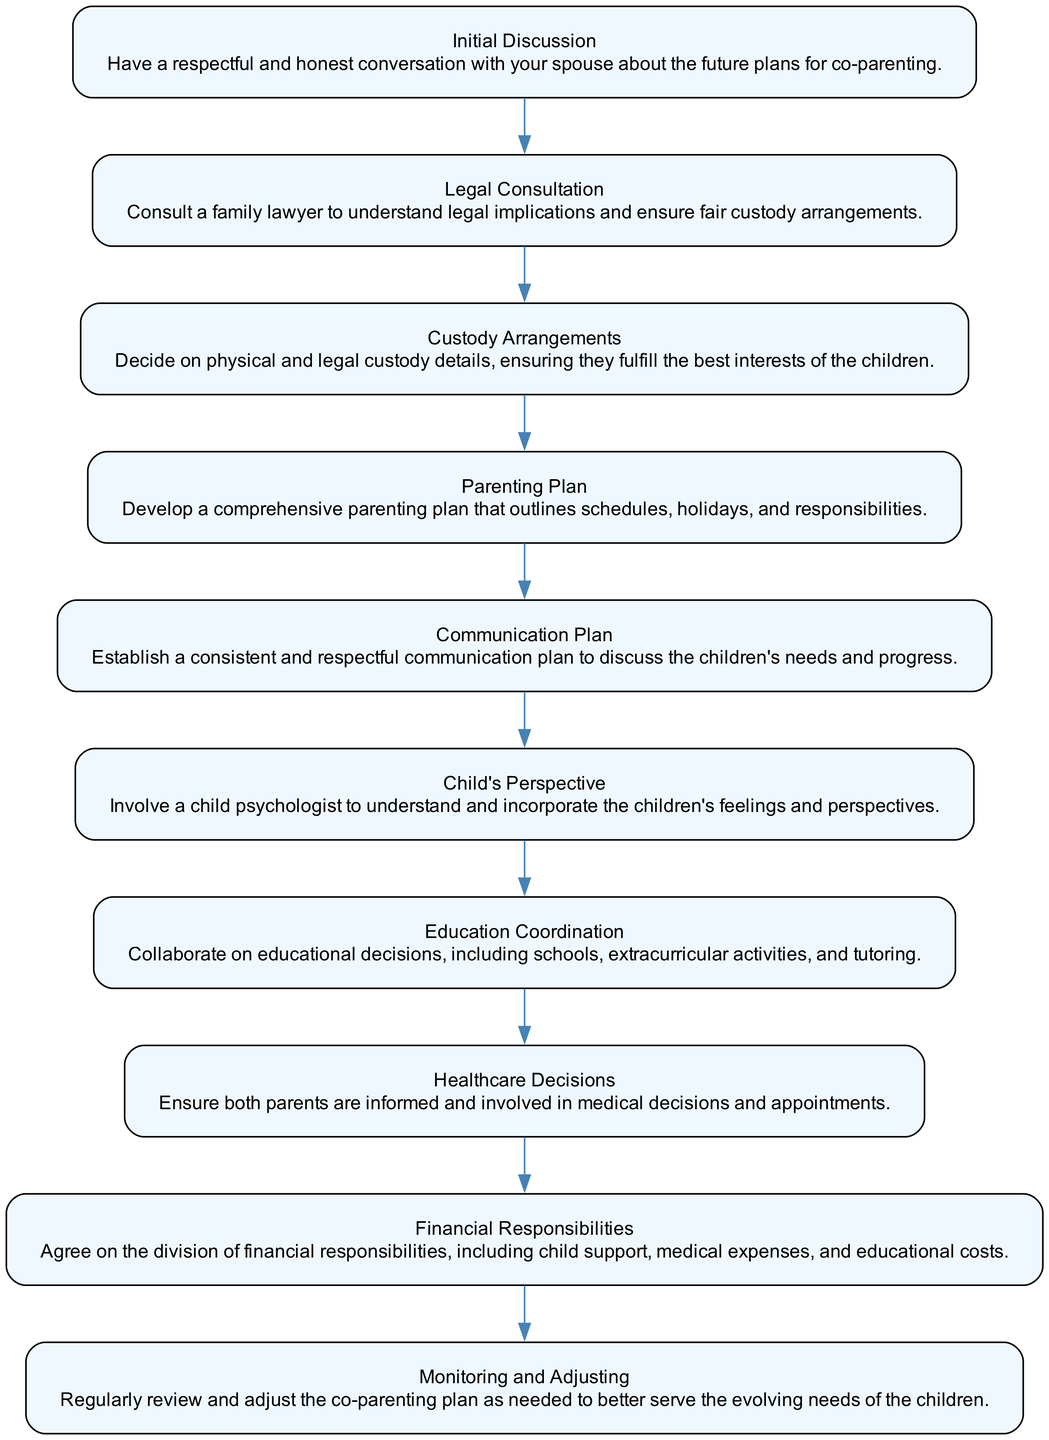What is the first step in the co-parenting strategies? The diagram indicates that the first step is "Initial Discussion," which involves having a respectful conversation about future plans for co-parenting.
Answer: Initial Discussion How many main nodes are there in the diagram? The total number of main nodes, representing different steps in the co-parenting process, is counted as each has been distinctly listed, resulting in ten nodes.
Answer: 10 What follows after the "Legal Consultation"? Following "Legal Consultation" in the flow is "Custody Arrangements," which indicates the next focus after understanding legal implications is to decide on custody details.
Answer: Custody Arrangements Which step emphasizes the children's feelings? The node named "Child's Perspective" highlights involving a child psychologist to ensure the children's feelings and perspectives are incorporated into the co-parenting plan.
Answer: Child's Perspective In the context of the diagram, what is the goal of the "Monitoring and Adjusting"? The "Monitoring and Adjusting" step aims to regularly review and modify the co-parenting plan to better accommodate the changing needs of the children as they grow.
Answer: Evolving needs of the children What type of decisions does "Education Coordination" focus on? "Education Coordination" focuses on decisions regarding schools, extracurricular activities, and tutoring, ensuring both parents collaborate on educational matters.
Answer: Educational decisions Which two steps are directly concerned with financial aspects? The steps that specifically address financial aspects are "Financial Responsibilities" and "Legal Consultation," where the first deals with division of expenses and the latter involves understanding custody implications potentially affecting finances.
Answer: Financial Responsibilities and Legal Consultation How does the step "Communication Plan" contribute to co-parenting? The "Communication Plan" establishes consistent and respectful communication between parents to discuss their children's needs and progress, thereby fostering collaboration post-divorce.
Answer: Consistent and respectful communication What is the purpose of the "Parenting Plan"? The "Parenting Plan" is intended to develop a comprehensive outline that specifies schedules, holidays, and responsibilities for both parents to ensure structured co-parenting.
Answer: Schedule, holidays, and responsibilities 